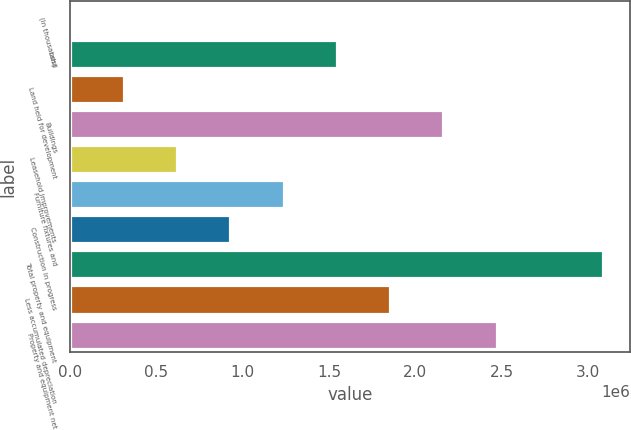Convert chart to OTSL. <chart><loc_0><loc_0><loc_500><loc_500><bar_chart><fcel>(In thousands)<fcel>Land<fcel>Land held for development<fcel>Buildings<fcel>Leasehold improvements<fcel>Furniture fixtures and<fcel>Construction in progress<fcel>Total property and equipment<fcel>Less accumulated depreciation<fcel>Property and equipment net<nl><fcel>2016<fcel>1.54452e+06<fcel>310516<fcel>2.16152e+06<fcel>619016<fcel>1.23602e+06<fcel>927516<fcel>3.08702e+06<fcel>1.85302e+06<fcel>2.47002e+06<nl></chart> 